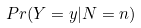<formula> <loc_0><loc_0><loc_500><loc_500>P r ( Y = y | N = n )</formula> 